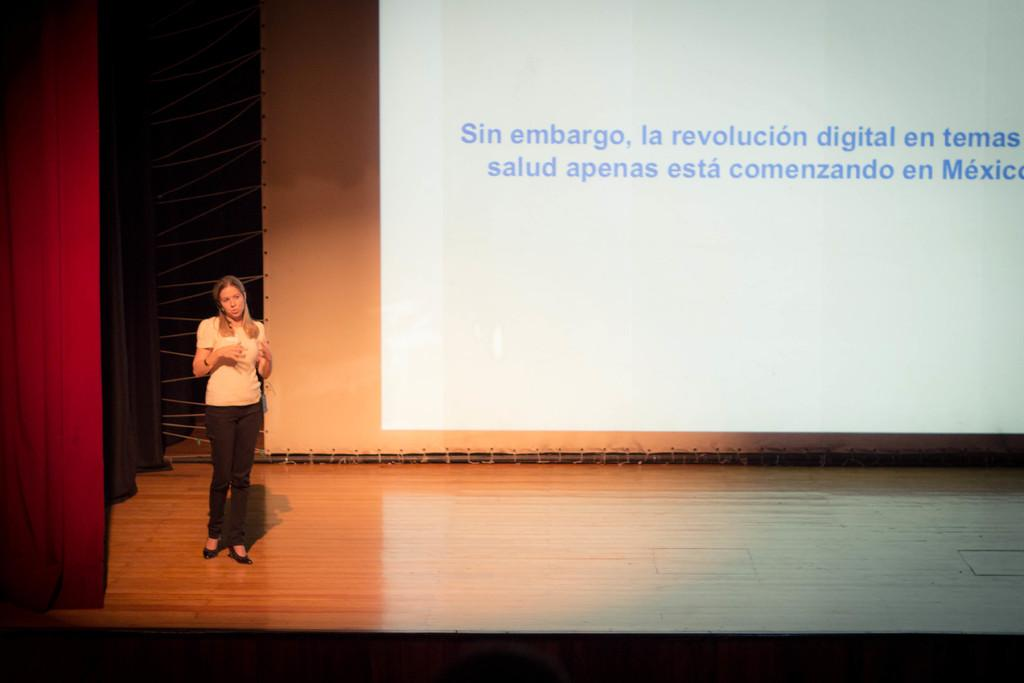What is the lady doing in the image? The lady is standing on a stage and talking. What can be seen behind the lady on the stage? There is a screen in the background. What type of curtains are present on the sides of the stage? There is a red curtain on the left side and a black curtain on the right side. What type of drug is the lady taking on stage? There is no indication in the image that the lady is taking any drug, and therefore no such activity can be observed. 